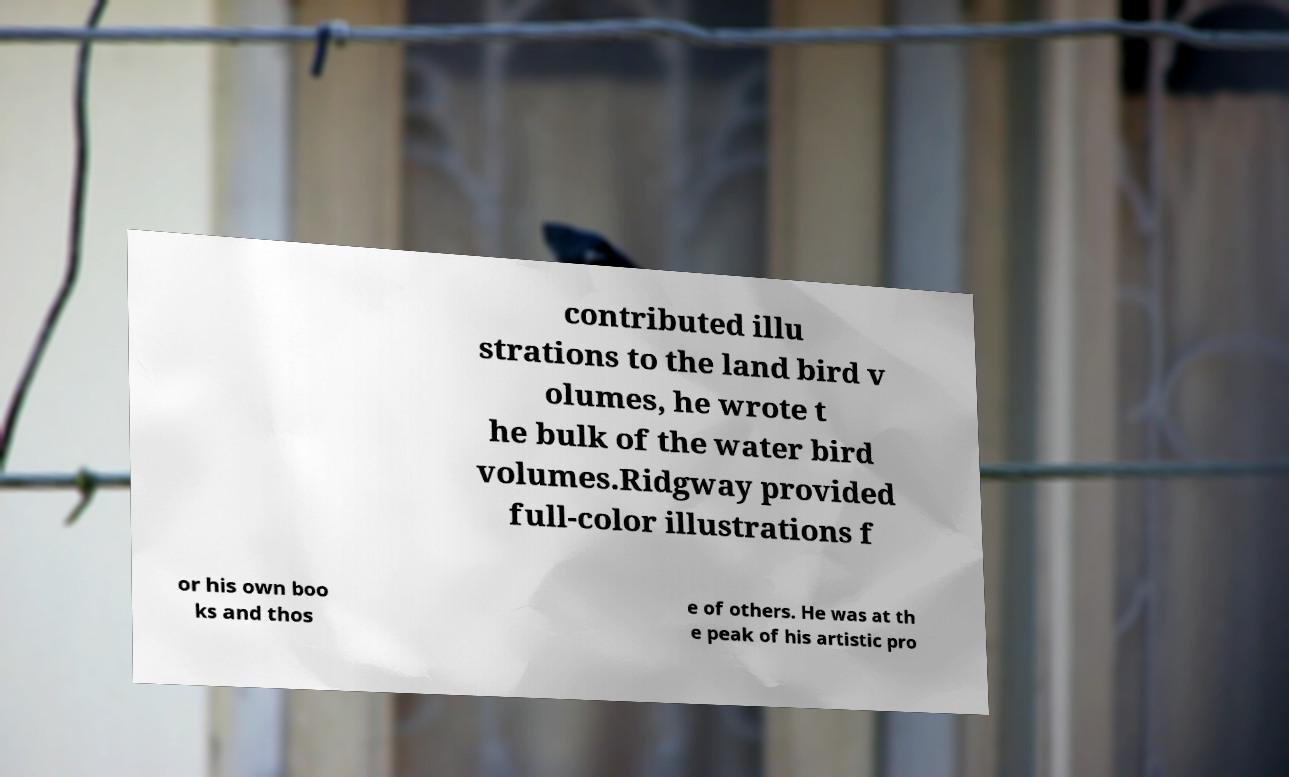Can you accurately transcribe the text from the provided image for me? contributed illu strations to the land bird v olumes, he wrote t he bulk of the water bird volumes.Ridgway provided full-color illustrations f or his own boo ks and thos e of others. He was at th e peak of his artistic pro 